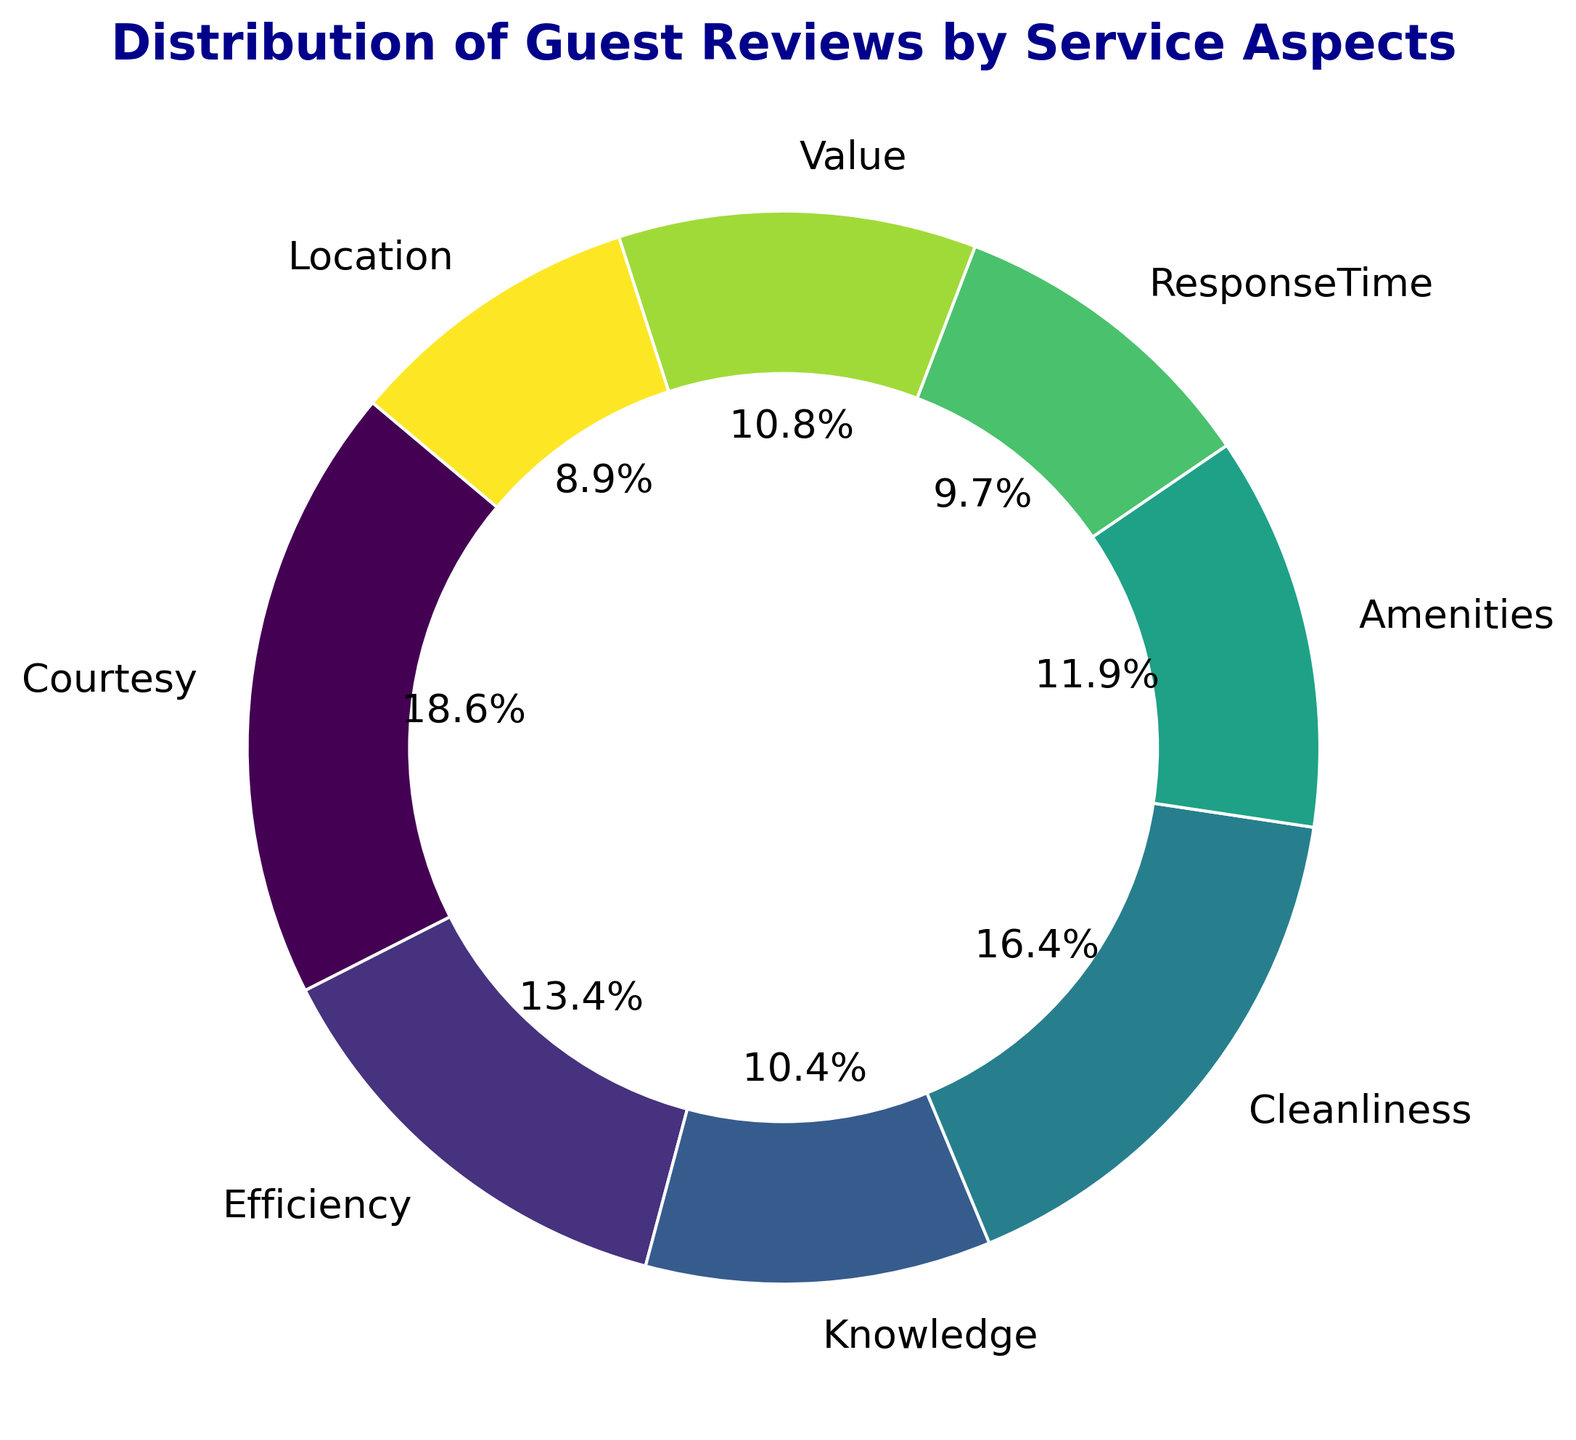Which service aspect received the most reviews? By observing the largest segment in the ring chart, we can see that Courtesy received the most reviews.
Answer: Courtesy Which service aspect received fewer reviews: Cleanliness or Knowledge? By comparing their respective segments in the ring chart, Cleanliness received more reviews than Knowledge.
Answer: Knowledge What is the percentage difference in reviews between Efficiency and Value? Efficiency has 180 reviews, and Value has 145 reviews. The percentage difference is calculated as ((180 - 145) / 180) * 100 = 19.4%.
Answer: 19.4% Which aspect has a larger proportion of reviews, ResponseTime or Location? By comparing the sizes of their segments in the ring chart, ResponseTime received more reviews than Location.
Answer: ResponseTime How many reviews are there in total for Courtesy, Cleanliness, and Amenities? Sum the reviews: Courtesy (250) + Cleanliness (220) + Amenities (160) = 630 reviews.
Answer: 630 What is the largest visual difference between any two service aspects? The largest visual difference can be observed between Courtesy (250 reviews) and Location (120 reviews), spanning a difference of 250 - 120 = 130 reviews in the ring chart.
Answer: 130 If you combine the reviews for Knowledge and Location, how do their combined reviews compare to the reviews of Courtesy? Knowledge has 140 reviews, and Location has 120 reviews, for a combined total of 140 + 120 = 260 reviews. Comparing to Courtesy's 250 reviews, the combination is slightly higher.
Answer: 260 Which service aspect's segment is visually closest in size to the Amenities segment? By visually assessing the segments, the Efficiency segment appears closest in size to the Amenities segment.
Answer: Efficiency What is the average number of reviews across all service aspects? Sum all reviews: 250+180+140+220+160+130+145+120 = 1345. There are 8 aspects, so the average is 1345 / 8 = 168.1 reviews.
Answer: 168.1 How do the reviews for Cleanliness compare to the average number of reviews across all service aspects? Cleanliness received 220 reviews, while the average number of reviews is 168.1. Cleanliness received more reviews than the average.
Answer: More reviews 